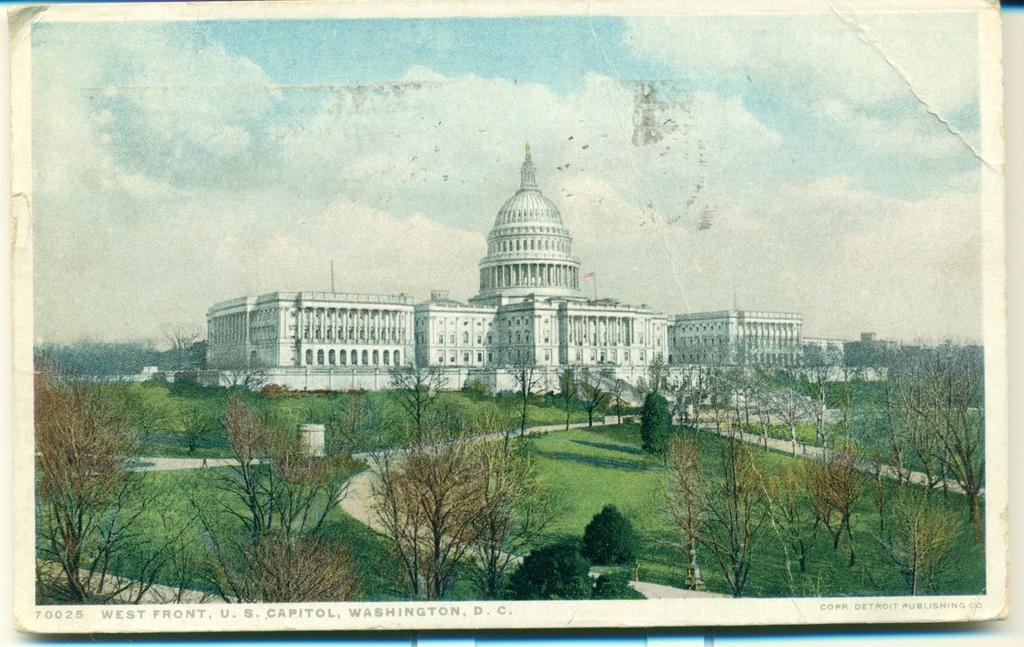Describe this image in one or two sentences. In this image we can see a poster of a place there are some trees, walkway and top of the image there is clear sky. 